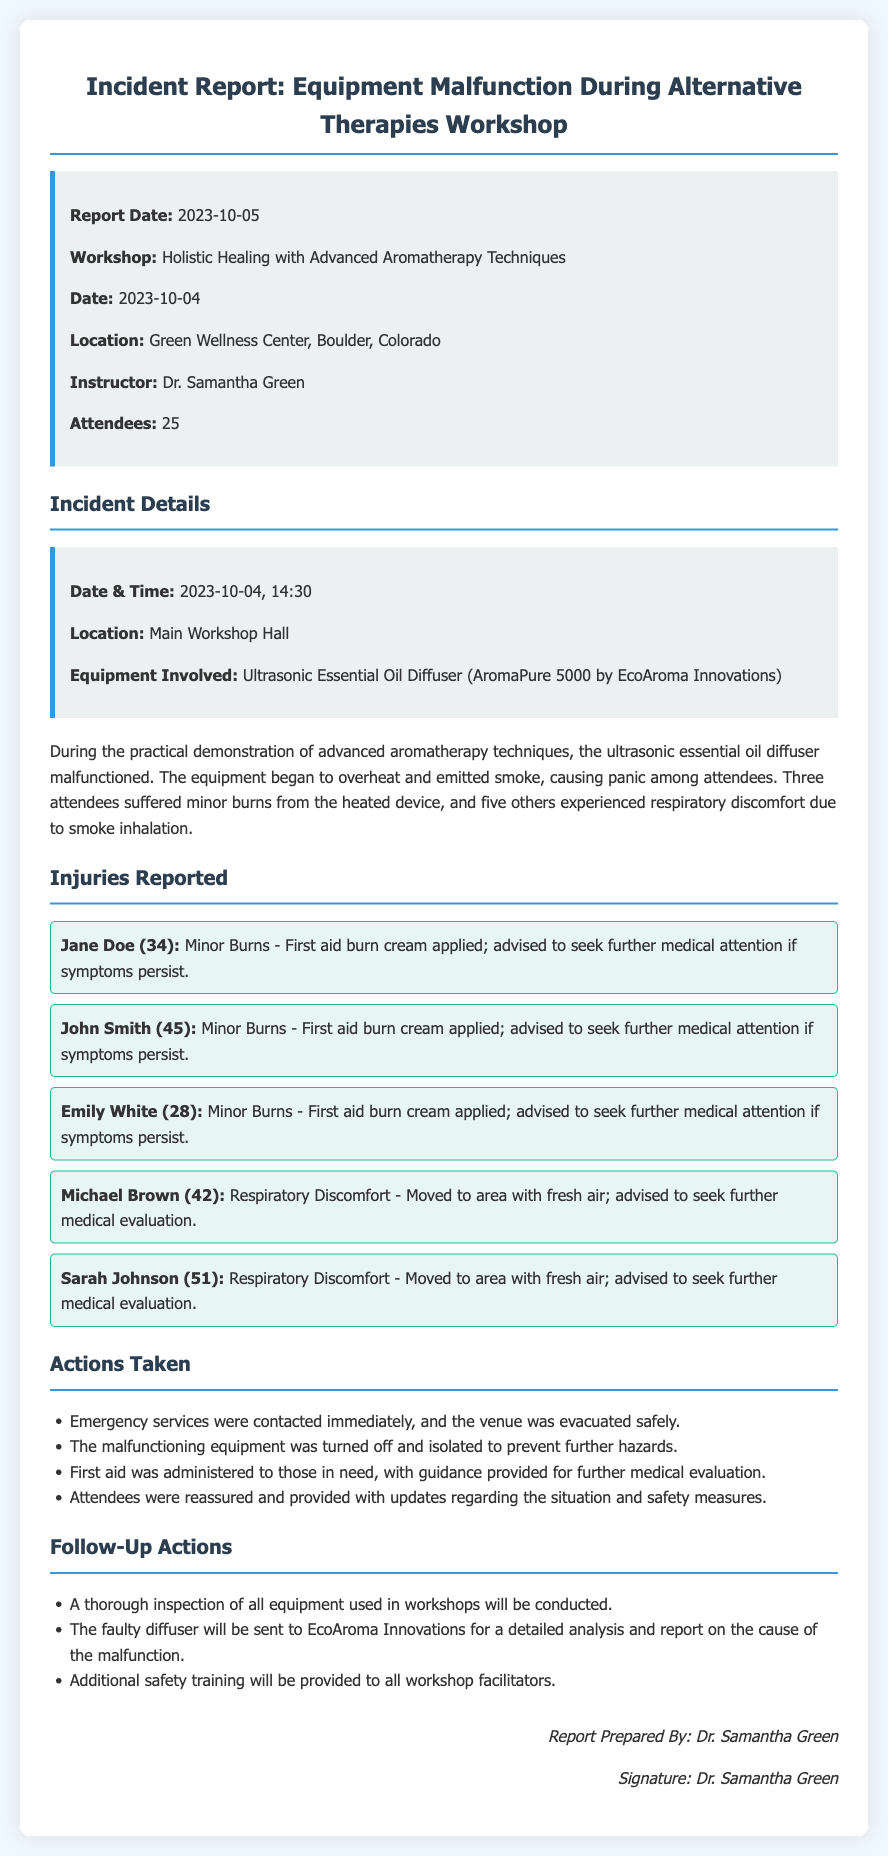What was the date of the incident? The incident occurred on the date specified in the report, which is 2023-10-04.
Answer: 2023-10-04 Who was the instructor for the workshop? The instructor's name is provided in the report as Dr. Samantha Green.
Answer: Dr. Samantha Green How many attendees were present during the workshop? The report states that there were a total of 25 attendees at the workshop.
Answer: 25 What type of equipment malfunctioned during the workshop? The equipment involved in the incident is identified as the Ultrasonic Essential Oil Diffuser (AromaPure 5000).
Answer: Ultrasonic Essential Oil Diffuser (AromaPure 5000) How many attendees suffered minor burns? The document lists three individuals who experienced minor burns during the incident.
Answer: 3 What action was taken immediately after the incident? The first action taken, as per the report, was to contact emergency services.
Answer: Contacting emergency services What will happen to the faulty diffuser? The report states that the faulty diffuser will be sent to EcoAroma Innovations for analysis.
Answer: Sent to EcoAroma Innovations What is one of the follow-up actions mentioned in the report? The report includes that a thorough inspection of all equipment will be conducted as a follow-up action.
Answer: Thorough inspection of all equipment 